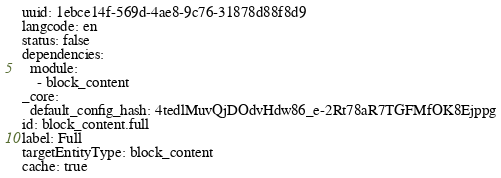Convert code to text. <code><loc_0><loc_0><loc_500><loc_500><_YAML_>uuid: 1ebce14f-569d-4ae8-9c76-31878d88f8d9
langcode: en
status: false
dependencies:
  module:
    - block_content
_core:
  default_config_hash: 4tedlMuvQjDOdvHdw86_e-2Rt78aR7TGFMfOK8Ejppg
id: block_content.full
label: Full
targetEntityType: block_content
cache: true
</code> 